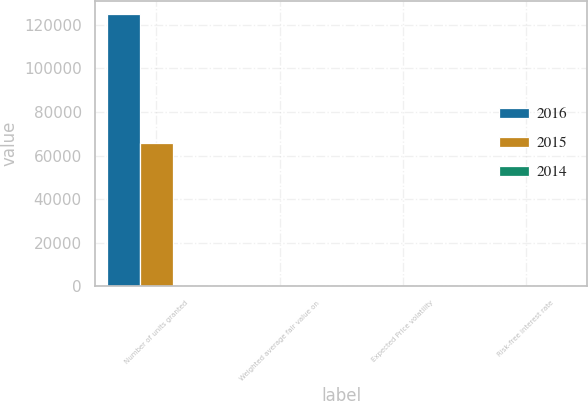Convert chart to OTSL. <chart><loc_0><loc_0><loc_500><loc_500><stacked_bar_chart><ecel><fcel>Number of units granted<fcel>Weighted average fair value on<fcel>Expected Price volatility<fcel>Risk-free interest rate<nl><fcel>2016<fcel>124755<fcel>57.14<fcel>26.5<fcel>0.98<nl><fcel>2015<fcel>65796<fcel>59.91<fcel>29.9<fcel>1.05<nl><fcel>2014<fcel>32.9<fcel>43.13<fcel>32.9<fcel>0.63<nl></chart> 